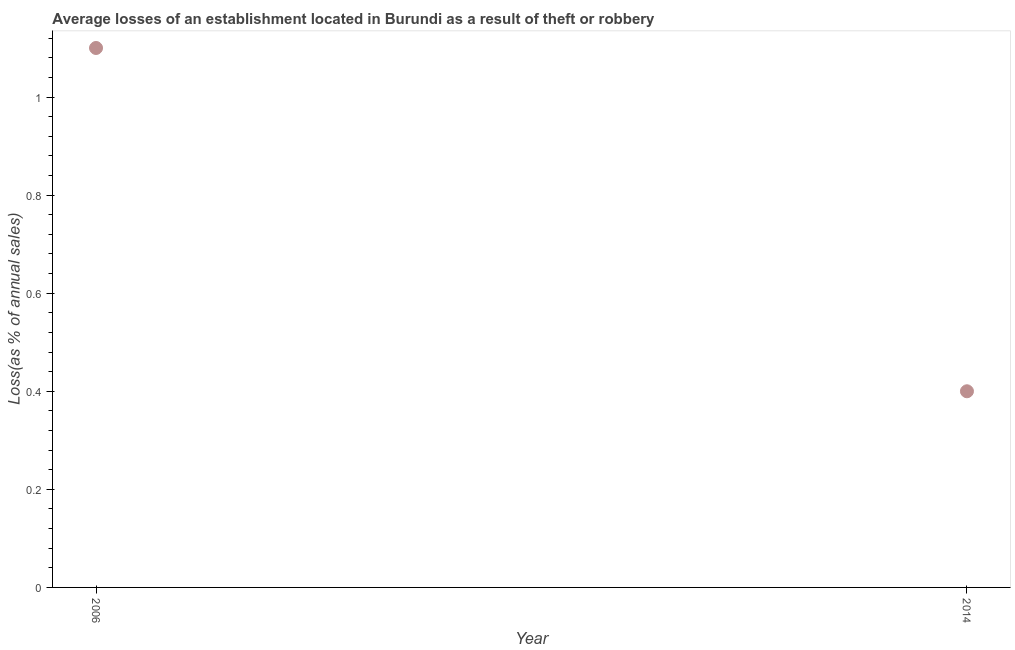Across all years, what is the maximum losses due to theft?
Your response must be concise. 1.1. In which year was the losses due to theft maximum?
Offer a terse response. 2006. In which year was the losses due to theft minimum?
Your answer should be compact. 2014. What is the sum of the losses due to theft?
Your response must be concise. 1.5. What is the difference between the losses due to theft in 2006 and 2014?
Provide a short and direct response. 0.7. Do a majority of the years between 2006 and 2014 (inclusive) have losses due to theft greater than 0.04 %?
Your response must be concise. Yes. What is the ratio of the losses due to theft in 2006 to that in 2014?
Provide a succinct answer. 2.75. In how many years, is the losses due to theft greater than the average losses due to theft taken over all years?
Keep it short and to the point. 1. Does the losses due to theft monotonically increase over the years?
Offer a very short reply. No. How many dotlines are there?
Give a very brief answer. 1. How many years are there in the graph?
Give a very brief answer. 2. Does the graph contain grids?
Your answer should be very brief. No. What is the title of the graph?
Your answer should be very brief. Average losses of an establishment located in Burundi as a result of theft or robbery. What is the label or title of the X-axis?
Provide a succinct answer. Year. What is the label or title of the Y-axis?
Provide a succinct answer. Loss(as % of annual sales). What is the Loss(as % of annual sales) in 2006?
Make the answer very short. 1.1. What is the Loss(as % of annual sales) in 2014?
Your response must be concise. 0.4. What is the ratio of the Loss(as % of annual sales) in 2006 to that in 2014?
Offer a terse response. 2.75. 